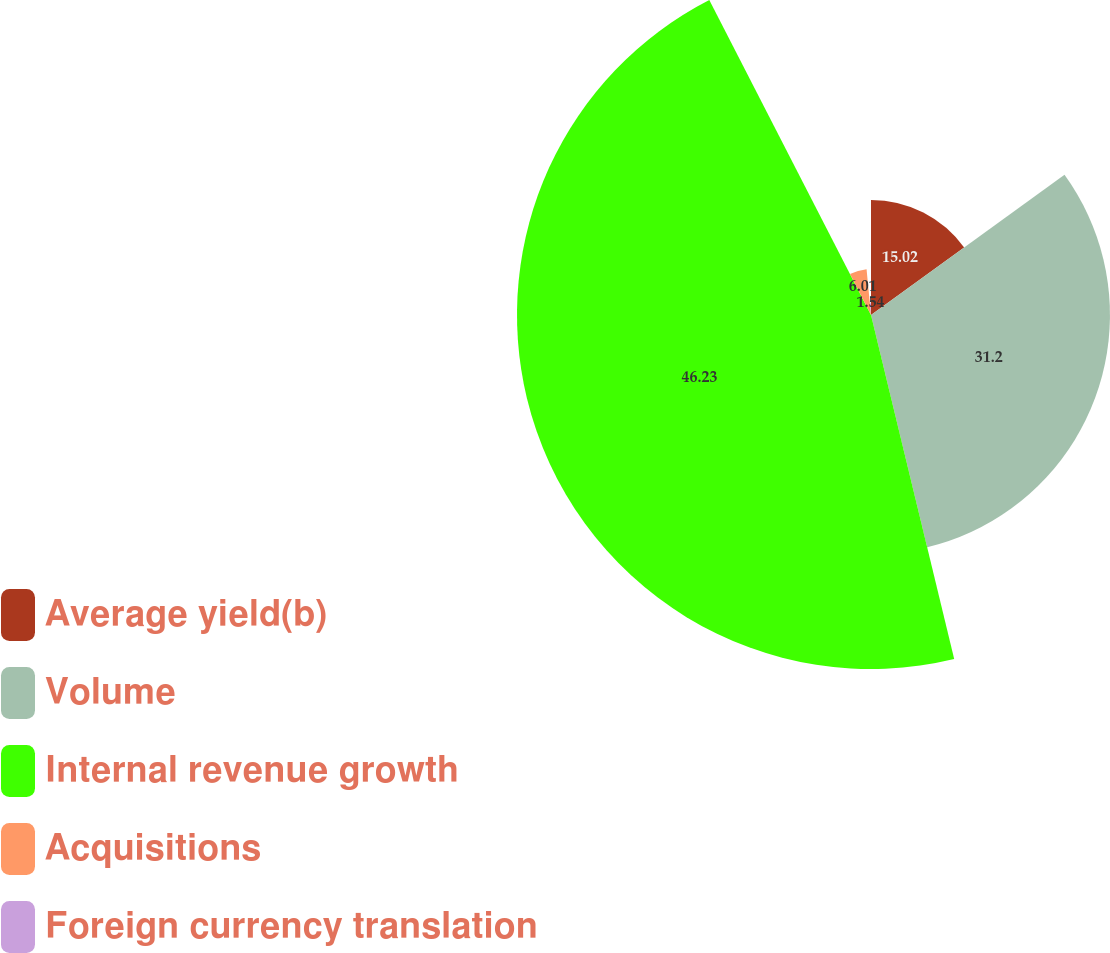Convert chart to OTSL. <chart><loc_0><loc_0><loc_500><loc_500><pie_chart><fcel>Average yield(b)<fcel>Volume<fcel>Internal revenue growth<fcel>Acquisitions<fcel>Foreign currency translation<nl><fcel>15.02%<fcel>31.2%<fcel>46.22%<fcel>6.01%<fcel>1.54%<nl></chart> 